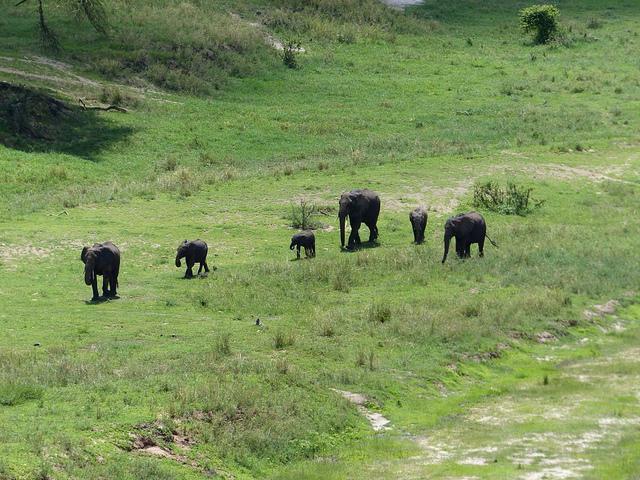Why might some of their trunks be curled?
Choose the correct response and explain in the format: 'Answer: answer
Rationale: rationale.'
Options: Eating, drinking, avoid tripping, trumpeting. Answer: eating.
Rationale: The trunks are curled to eat. What is the littlest elephant called?
Indicate the correct response and explain using: 'Answer: answer
Rationale: rationale.'
Options: Pup, colt, squab, calf. Answer: calf.
Rationale: The other options apply to dogs, horses and pigeons. 